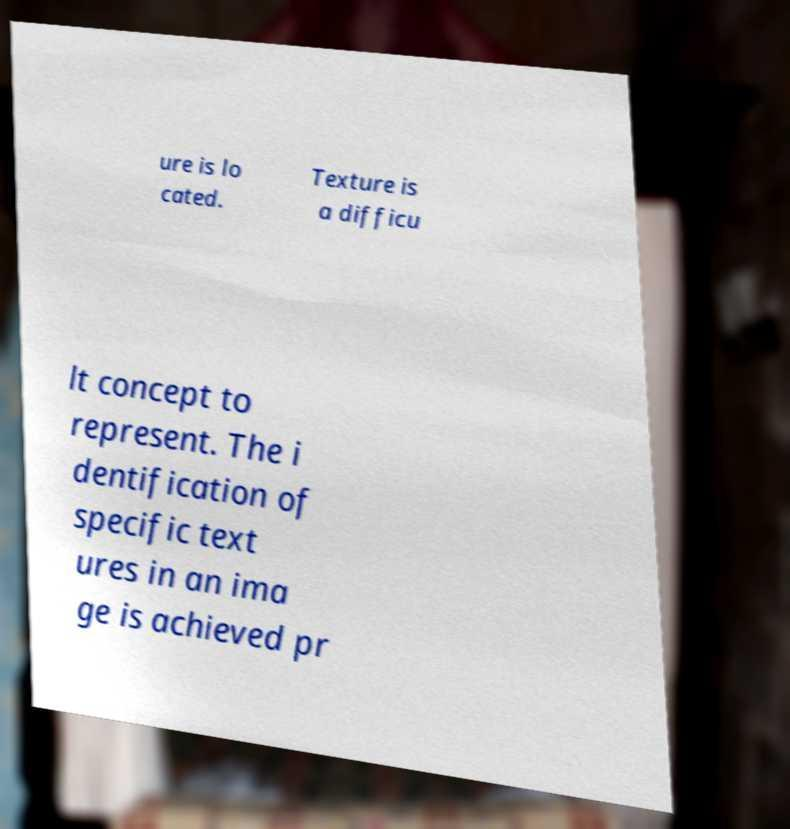Can you read and provide the text displayed in the image?This photo seems to have some interesting text. Can you extract and type it out for me? ure is lo cated. Texture is a difficu lt concept to represent. The i dentification of specific text ures in an ima ge is achieved pr 